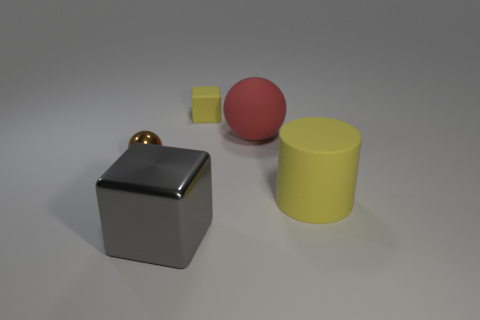Add 4 tiny yellow matte cylinders. How many objects exist? 9 Subtract all cylinders. How many objects are left? 4 Subtract all brown matte cubes. Subtract all gray objects. How many objects are left? 4 Add 4 red rubber balls. How many red rubber balls are left? 5 Add 3 small matte objects. How many small matte objects exist? 4 Subtract 0 yellow spheres. How many objects are left? 5 